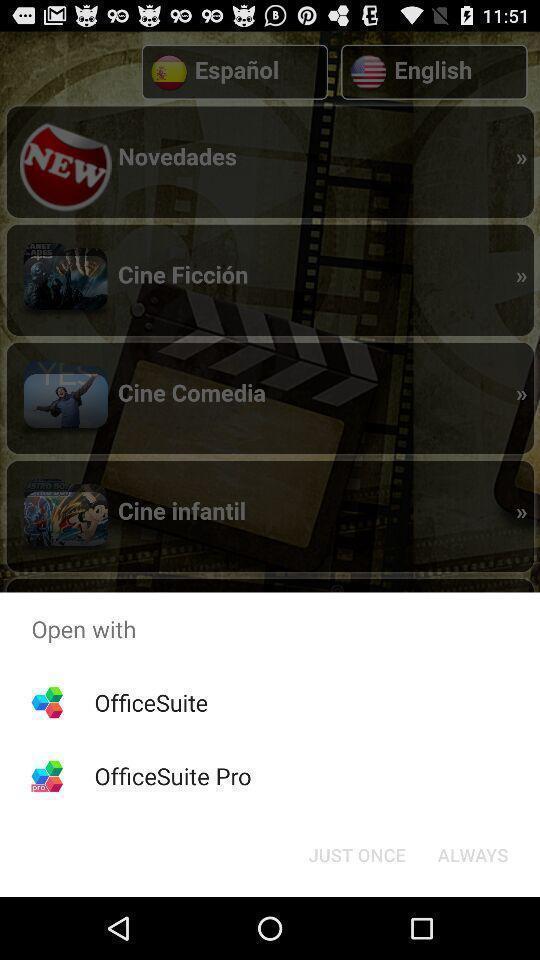Tell me about the visual elements in this screen capture. Push up page showing app preference to open. 